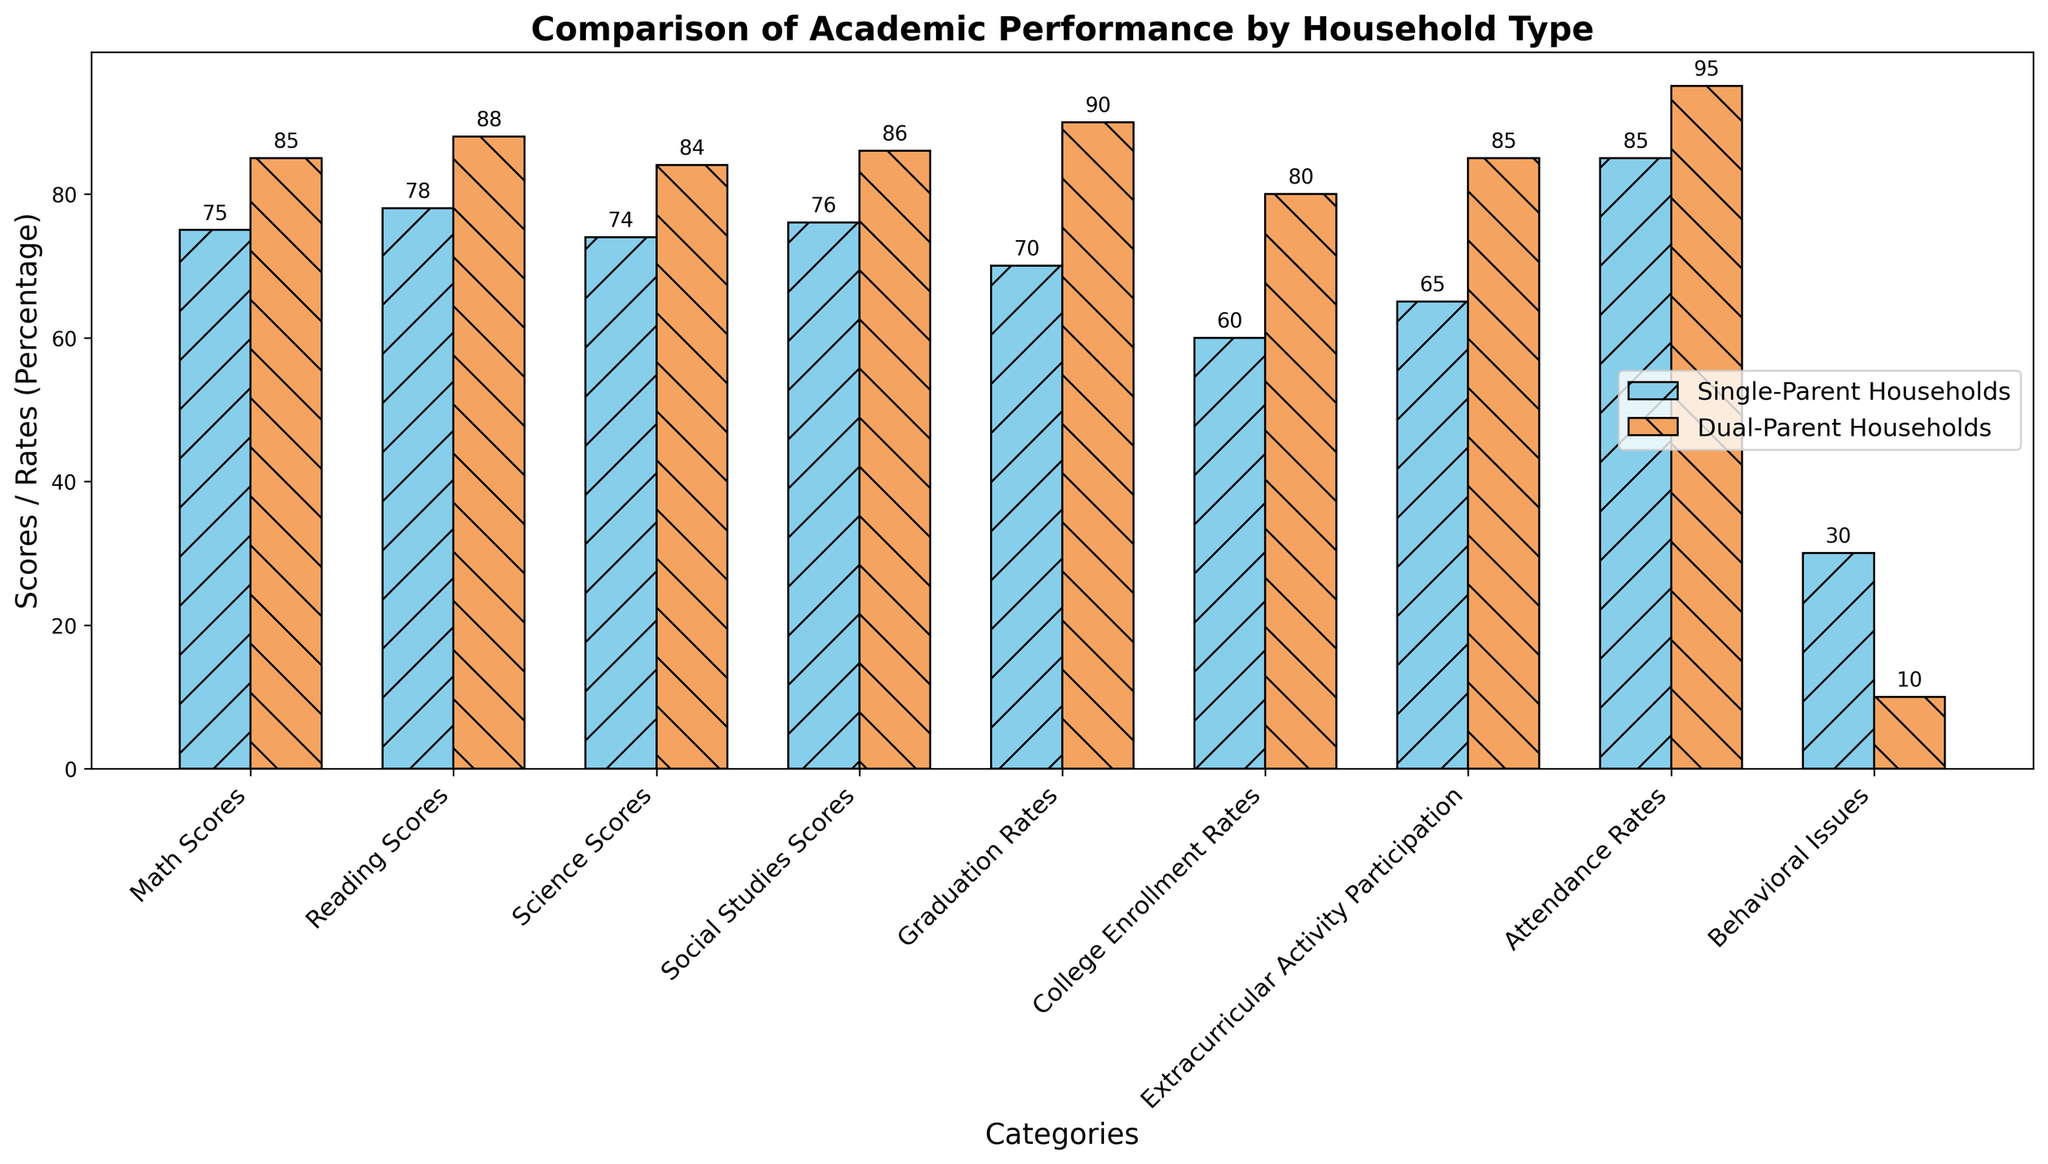What is the difference in Math Scores between children from single-parent households and dual-parent households? Subtract the Math Scores of single-parent households (75) from dual-parent households (85): 85 - 75 = 10
Answer: 10 Which household type shows a higher participation rate in extracurricular activities? Compare the values for Extracurricular Activity Participation: single-parent households (65) and dual-parent households (85); dual-parent households have a higher participation rate.
Answer: Dual-Parent Households What is the total score for Reading and Science for children from single-parent households? Add the Reading Scores (78) and Science Scores (74) for single-parent households: 78 + 74 = 152
Answer: 152 Which data category has the most significant behavioral issues difference between single-parent and dual-parent households? Compare the difference in Behavioral Issues: 30 (single-parent) - 10 (dual-parent) = 20; this is the highest category difference.
Answer: Behavioral Issues What is the average Graduation Rate for both household types combined? Add Graduation Rates (70 for single-parent and 90 for dual-parent) and divide by 2: (70 + 90) / 2 = 80
Answer: 80 Which household type has a higher attendance rate, and by how much? Compare Attendance Rates: dual-parent households (95) - single-parent households (85) = 10; dual-parent households have a higher rate.
Answer: Dual-Parent Households by 10 What is the sum of College Enrollment Rates for both household types? Add College Enrollment Rates for single-parent (60) and dual-parent households (80): 60 + 80 = 140
Answer: 140 Which color represents single-parent households in the bar chart? Identify the color of the bars for single-parent households: sky blue
Answer: Sky blue What category, apart from Behavioral Issues, shows the largest percentage difference between the two household types? Calculate differences, besides Behavioral Issues: Math (10), Social Studies (10), Graduation Rates (20), College Enrollment Rates (20); the largest is Graduation Rates or College Enrollment Rates.
Answer: Graduation Rates or College Enrollment Rates What is the total attendance rate for both household types combined? Add Attendance Rates for single-parent (85) and dual-parent households (95): 85 + 95 = 180
Answer: 180 